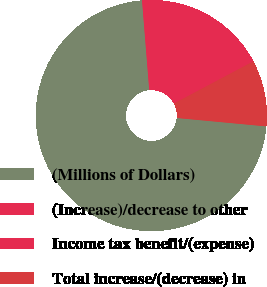Convert chart to OTSL. <chart><loc_0><loc_0><loc_500><loc_500><pie_chart><fcel>(Millions of Dollars)<fcel>(Increase)/decrease to other<fcel>Income tax benefit/(expense)<fcel>Total increase/(decrease) in<nl><fcel>72.23%<fcel>16.25%<fcel>2.26%<fcel>9.26%<nl></chart> 